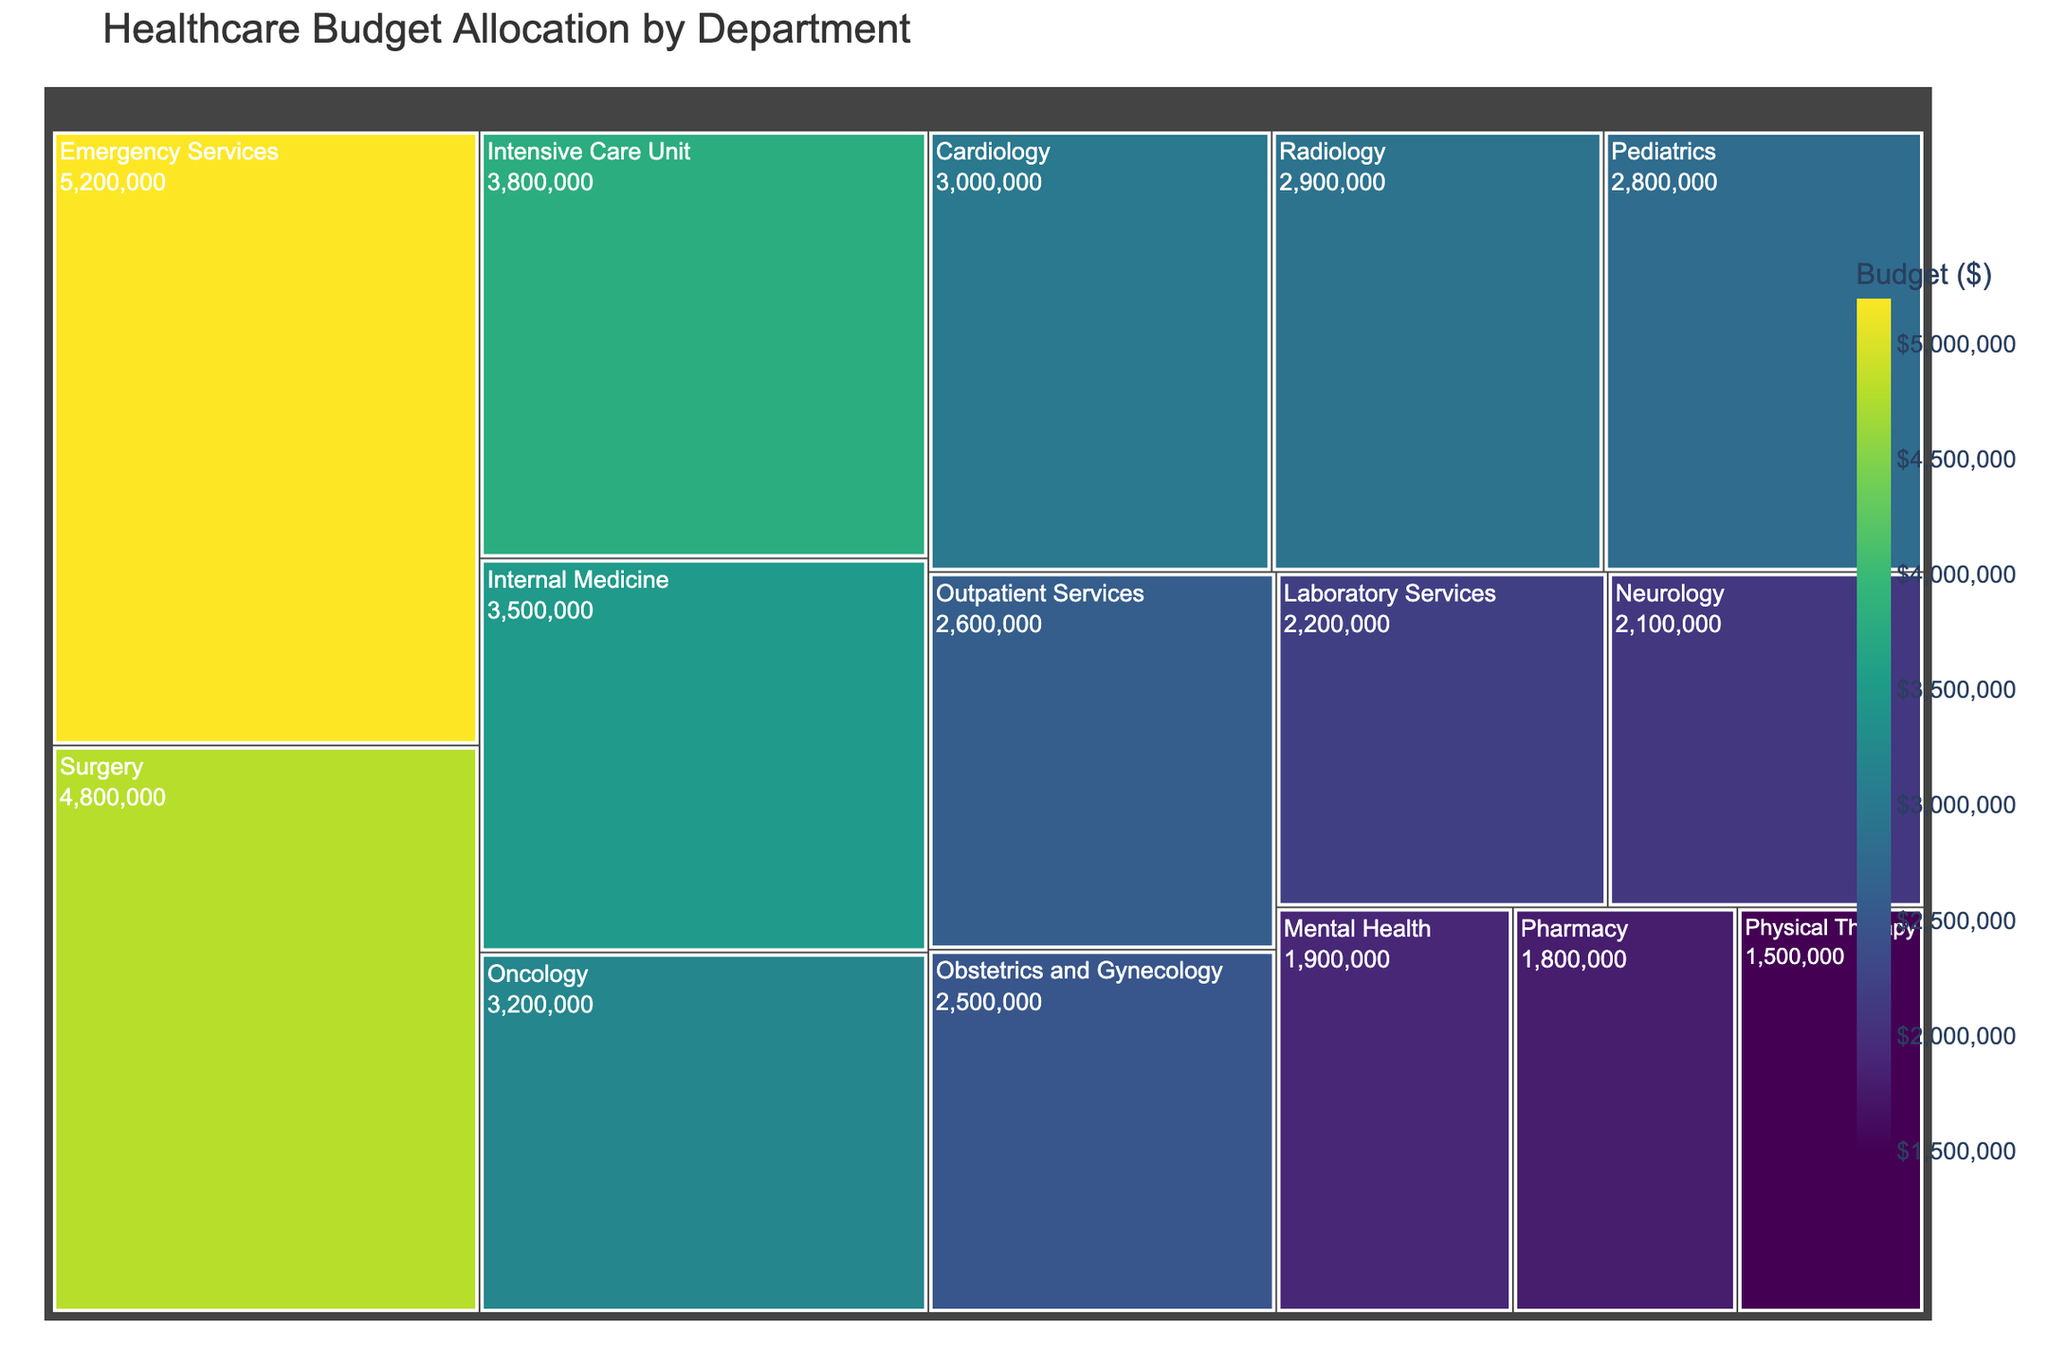Which department has the highest budget allocation? The Treemap clearly shows the sizes of each department. The largest area corresponds to the Emergency Services department.
Answer: Emergency Services What is the budget allocated to the Surgery department? Check the Surgery department's box in the Treemap and look at the value inside it.
Answer: $4,800,000 How does the budget for the Pediatrics department compare to the Obstetrics and Gynecology department? Find the boxes for Pediatrics and Obstetrics and Gynecology in the Treemap and compare the values inside them. Pediatrics has a budget of $2,800,000, which is higher than Obstetrics and Gynecology's $2,500,000.
Answer: Pediatrics has a higher budget What is the combined budget for Radiology and Oncology? Add the budget values for Radiology ($2,900,000) and Oncology ($3,200,000).
Answer: $6,100,000 Which department has a smaller budget allocation: Mental Health or Pharmacy? Compare the Mental Health budget ($1,900,000) to the Pharmacy budget ($1,800,000).
Answer: Pharmacy has a smaller budget What is the total budget allocated to all departments combined? Sum the budgets of all departments listed: 5200000 + 4800000 + 3500000 + 2800000 + 2500000 + 3200000 + 2900000 + 2200000 + 1800000 + 2100000 + 3000000 + 3800000 + 2600000 + 1500000 + 1900000.
Answer: $44,000,000 How does the budget of the Intensive Care Unit compare to the Laboratory Services? Look at the Intensive Care Unit box value ($3,800,000) and Laboratory Services box value ($2,200,000) and compare them.
Answer: Intensive Care Unit has a higher budget Which department has the smallest budget allocation and what is its value? Find the smallest box in the Treemap, which corresponds to Physical Therapy.
Answer: Physical Therapy, $1,500,000 What percentage of the total budget is allocated to the Internal Medicine department? Divide Internal Medicine's budget ($3,500,000) by the total budget ($44,000,000) and multiply by 100 to get the percentage. (3,500,000 / 44,000,000) * 100
Answer: 7.95% Is the budget for Cardiology higher than that for Neurology? Compare the Cardiology budget ($3,000,000) and the Neurology budget ($2,100,000).
Answer: Yes, Cardiology has a higher budget 